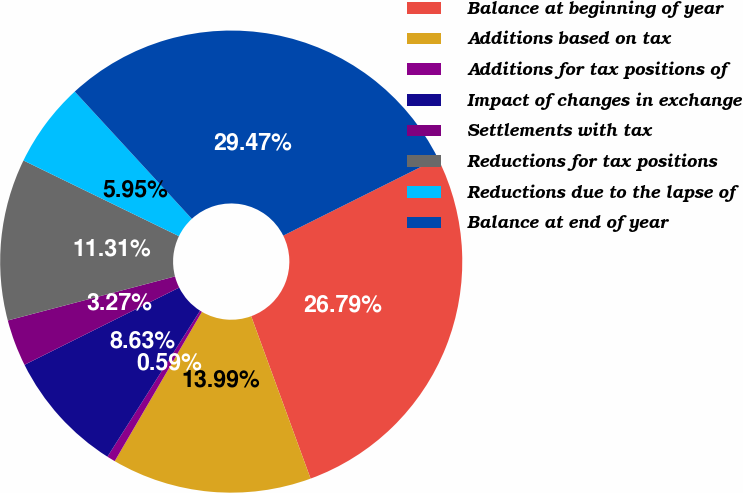Convert chart. <chart><loc_0><loc_0><loc_500><loc_500><pie_chart><fcel>Balance at beginning of year<fcel>Additions based on tax<fcel>Additions for tax positions of<fcel>Impact of changes in exchange<fcel>Settlements with tax<fcel>Reductions for tax positions<fcel>Reductions due to the lapse of<fcel>Balance at end of year<nl><fcel>26.79%<fcel>13.99%<fcel>0.59%<fcel>8.63%<fcel>3.27%<fcel>11.31%<fcel>5.95%<fcel>29.47%<nl></chart> 